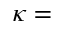Convert formula to latex. <formula><loc_0><loc_0><loc_500><loc_500>\kappa =</formula> 